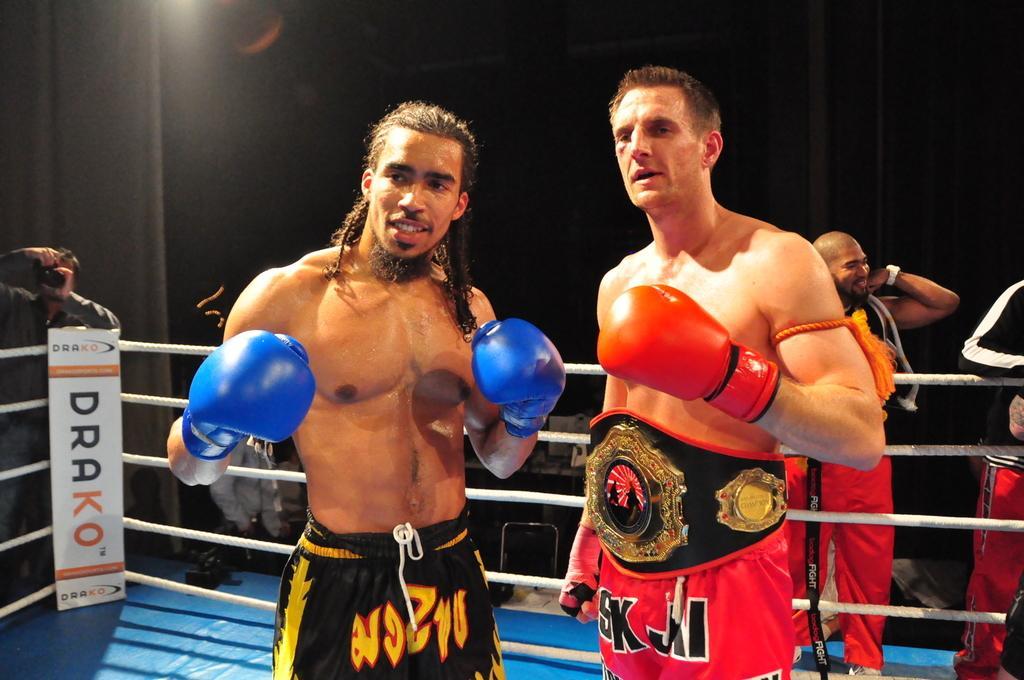Can you describe this image briefly? In this picture I can see few people are standing on the stage and couple of them worn boxing gloves and a man wore a belt to his waist and I can see a man standing and holding a camera and taking picture and I can see a board with some text and I can see few people on the back. 